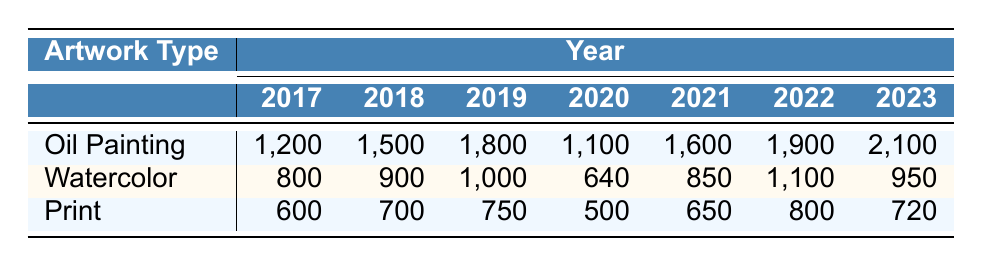What was the highest attendance for Oil Paintings? The highest attendance for Oil Paintings can be found by looking at the values in the Oil Painting row. The attendance figures are 1,200 in 2017, 1,500 in 2018, 1,800 in 2019, 1,100 in 2020, 1,600 in 2021, 1,900 in 2022, and 2,100 in 2023. The highest value is 2,100 in 2023.
Answer: 2,100 Which artwork type had the lowest attendance in 2020? To find the lowest attendance in 2020, we look at the attendance values for each artwork type in that year: Oil Painting had 1,100, Watercolor had 640, and Print had 500. The lowest of these is the Print at 500.
Answer: Print What is the total attendance for Watercolors from 2017 to 2023? The total attendance for Watercolors can be calculated by summing their attendance figures from each year: 800 (2017) + 900 (2018) + 1,000 (2019) + 640 (2020) + 850 (2021) + 1,100 (2022) + 950 (2023) = 5,240.
Answer: 5,240 Did the attendance for Print artworks increase in 2022 compared to 2021? In 2022, Print attendance was 800, while in 2021 it was 650. Since 800 is greater than 650, the attendance for Print artworks did increase from 2021 to 2022.
Answer: Yes What was the average attendance of Oil Paintings over the seven years? To find the average attendance of Oil Paintings, we first sum the attendance figures: 1,200 + 1,500 + 1,800 + 1,100 + 1,600 + 1,900 + 2,100 = 11,300. Then, we divide this by the number of years, which is 7. The average is 11,300 / 7 = 1,614.29, which can be rounded to 1,614.
Answer: 1,614 